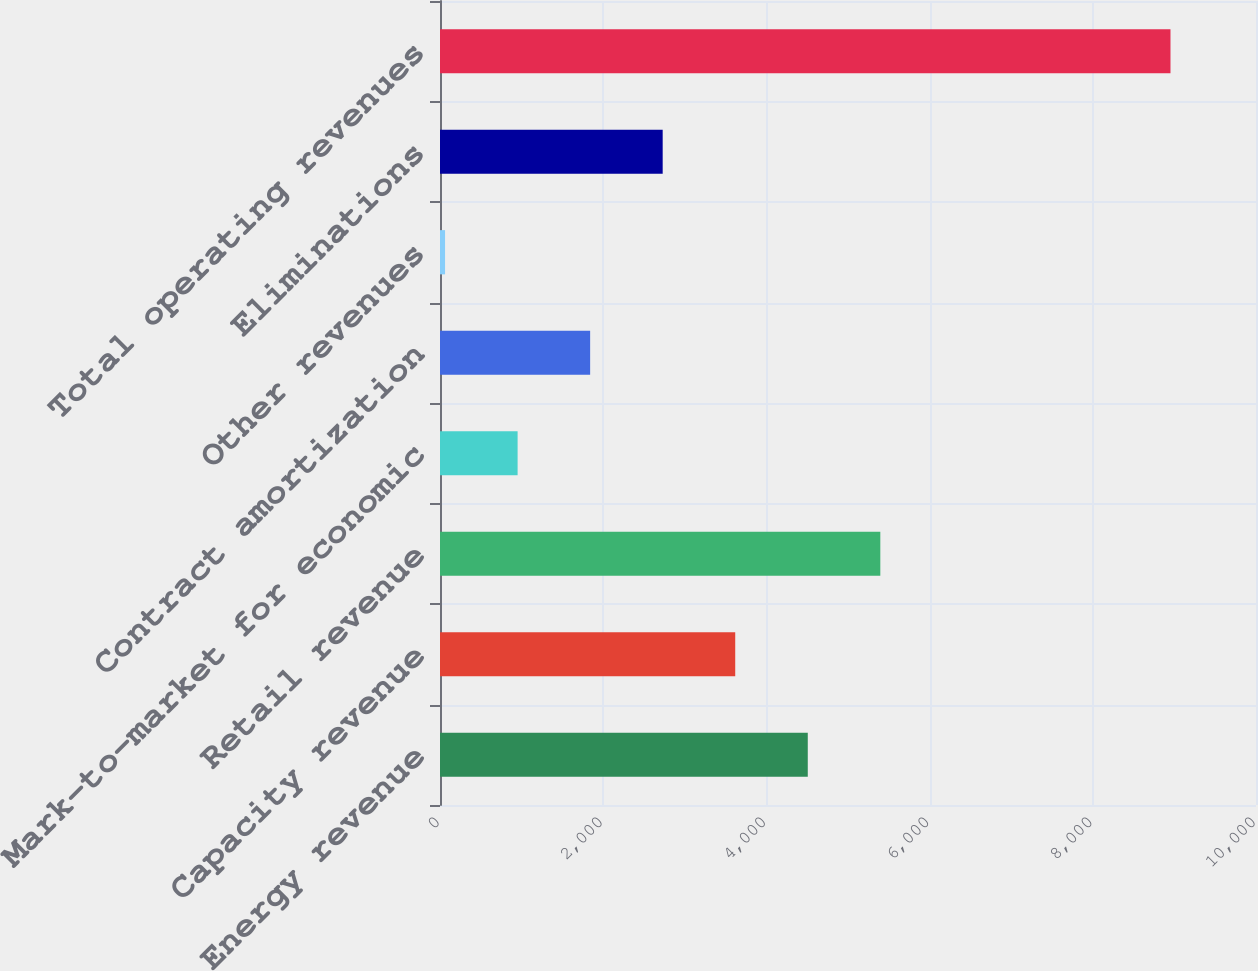Convert chart. <chart><loc_0><loc_0><loc_500><loc_500><bar_chart><fcel>Energy revenue<fcel>Capacity revenue<fcel>Retail revenue<fcel>Mark-to-market for economic<fcel>Contract amortization<fcel>Other revenues<fcel>Eliminations<fcel>Total operating revenues<nl><fcel>4507<fcel>3618<fcel>5396<fcel>951<fcel>1840<fcel>62<fcel>2729<fcel>8952<nl></chart> 